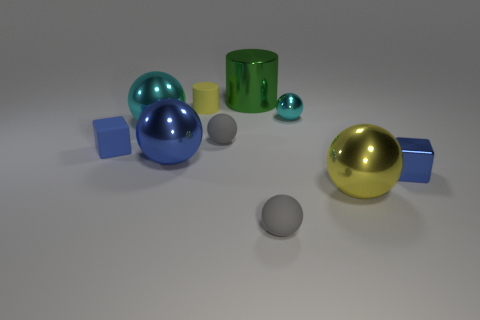What number of green things are either cylinders or small shiny spheres?
Provide a succinct answer. 1. What is the shape of the large blue shiny object?
Provide a succinct answer. Sphere. What number of other objects are the same shape as the large blue thing?
Your answer should be very brief. 5. What is the color of the small object that is behind the tiny cyan metal sphere?
Your answer should be very brief. Yellow. Is the small yellow object made of the same material as the small cyan sphere?
Give a very brief answer. No. How many things are either big blue things or blue metallic objects that are on the left side of the small cyan object?
Ensure brevity in your answer.  1. There is a metallic object that is the same color as the matte cylinder; what is its size?
Ensure brevity in your answer.  Large. There is a rubber thing right of the big green metal cylinder; what is its shape?
Offer a very short reply. Sphere. There is a large sphere behind the tiny blue matte cube; does it have the same color as the metal block?
Your response must be concise. No. What material is the tiny object that is the same color as the tiny metallic block?
Your response must be concise. Rubber. 